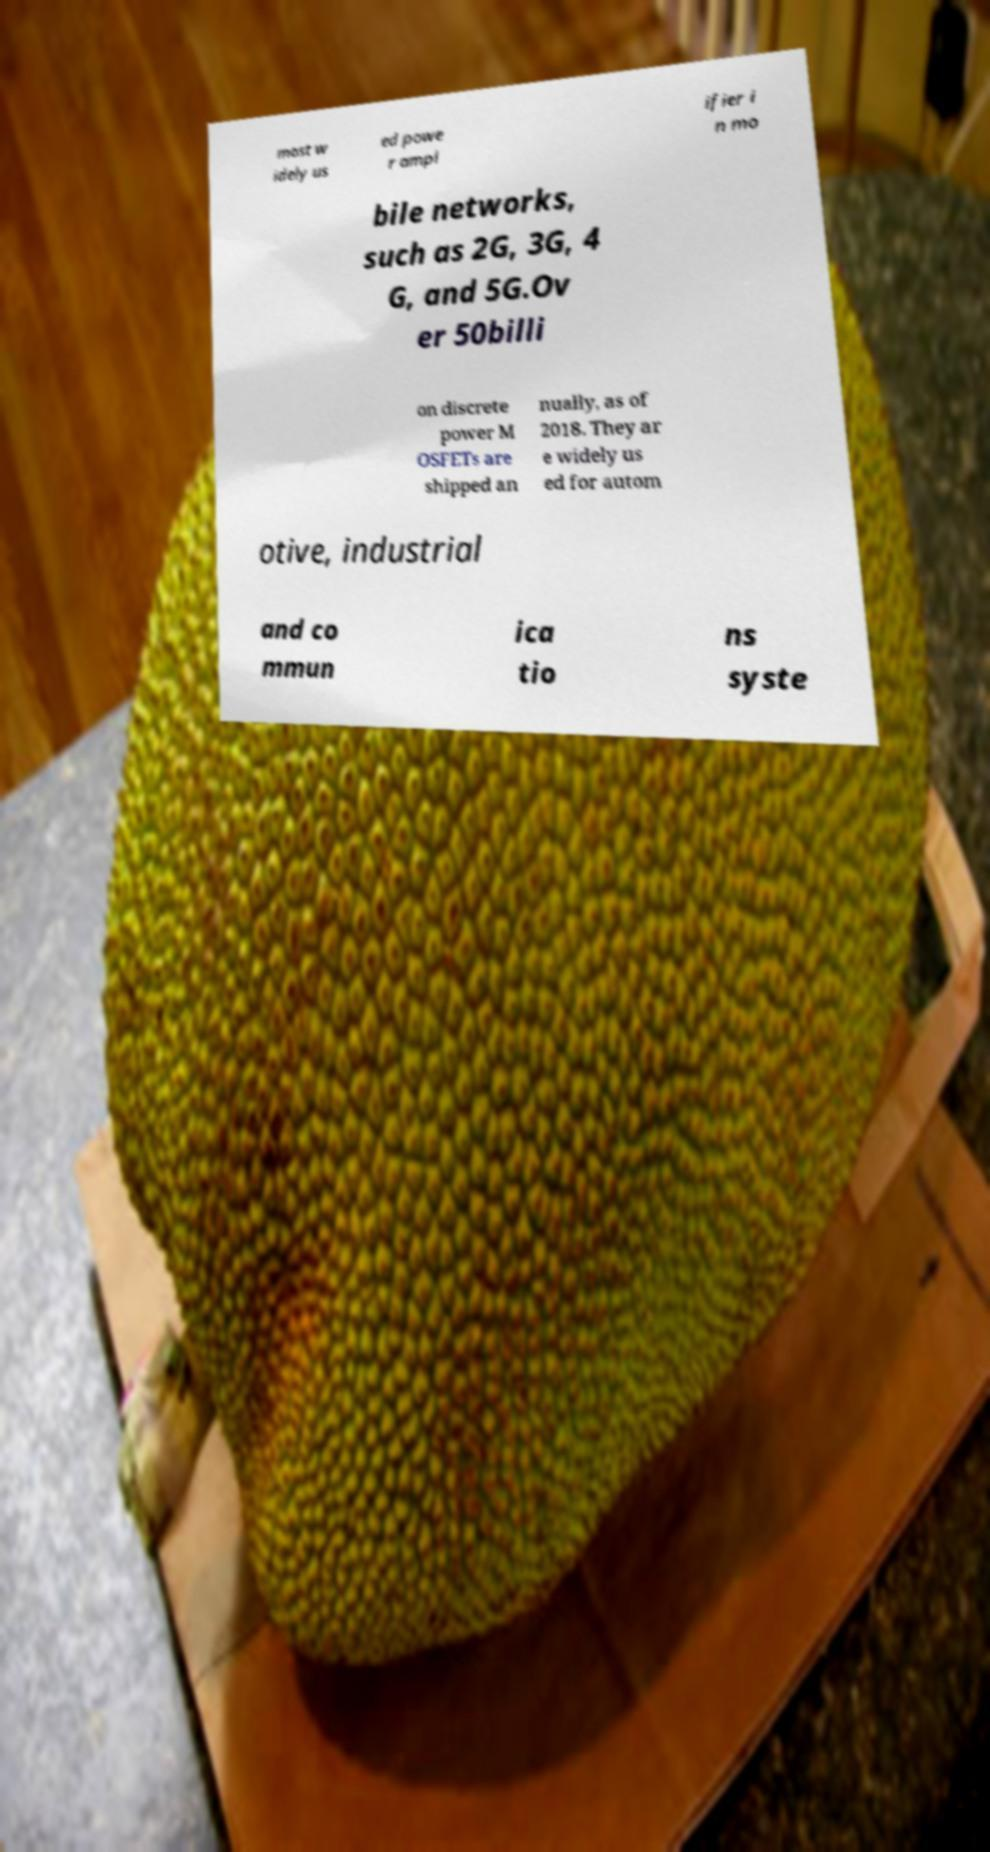There's text embedded in this image that I need extracted. Can you transcribe it verbatim? most w idely us ed powe r ampl ifier i n mo bile networks, such as 2G, 3G, 4 G, and 5G.Ov er 50billi on discrete power M OSFETs are shipped an nually, as of 2018. They ar e widely us ed for autom otive, industrial and co mmun ica tio ns syste 